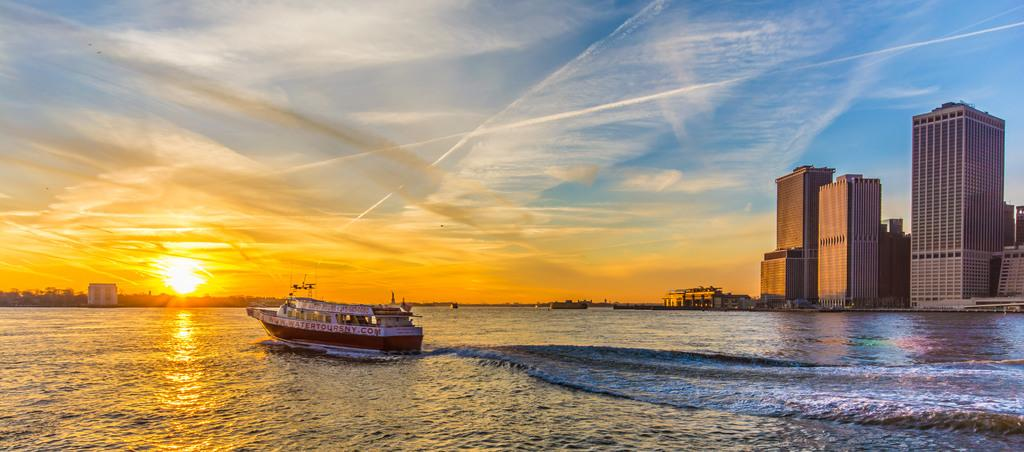What type of vehicle is on the water in the image? There is a speed boat on the water in the image. What structures can be seen in the image? Buildings are visible in the image. What type of vegetation is present in the image? Trees are present in the image. What is visible in the sky in the image? The sun is visible in the sky, and there are clouds present. What is the name of the society that owns the speed boat in the image? There is no information about a society owning the speed boat in the image, nor is there any indication of a society present. 